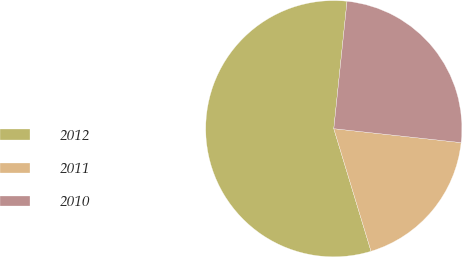Convert chart to OTSL. <chart><loc_0><loc_0><loc_500><loc_500><pie_chart><fcel>2012<fcel>2011<fcel>2010<nl><fcel>56.34%<fcel>18.57%<fcel>25.09%<nl></chart> 